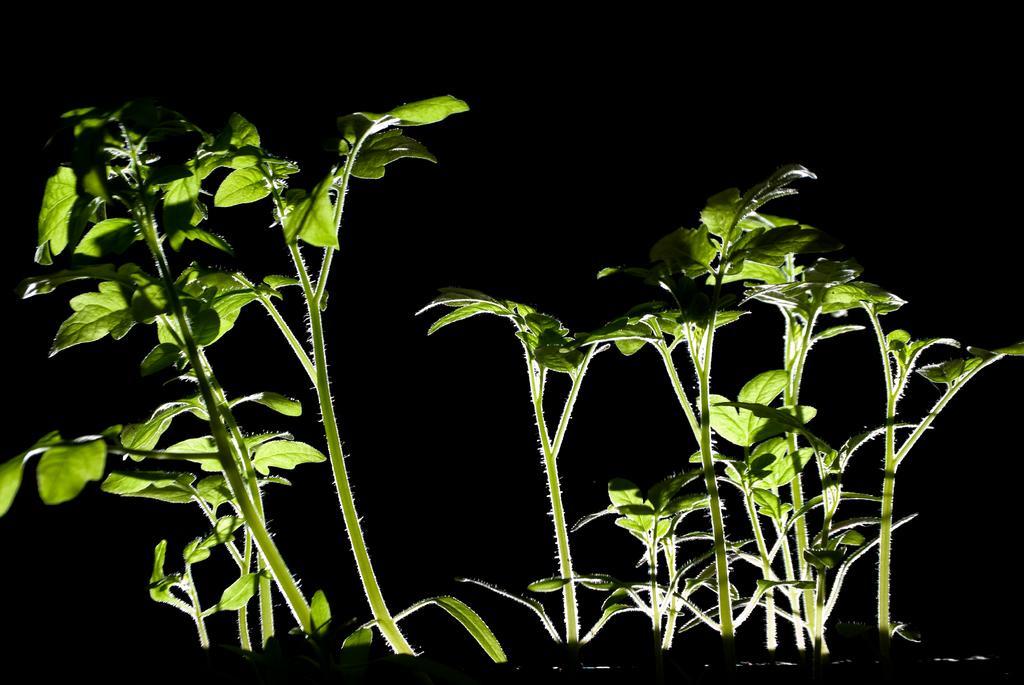Describe this image in one or two sentences. In this image we can see some plants. 